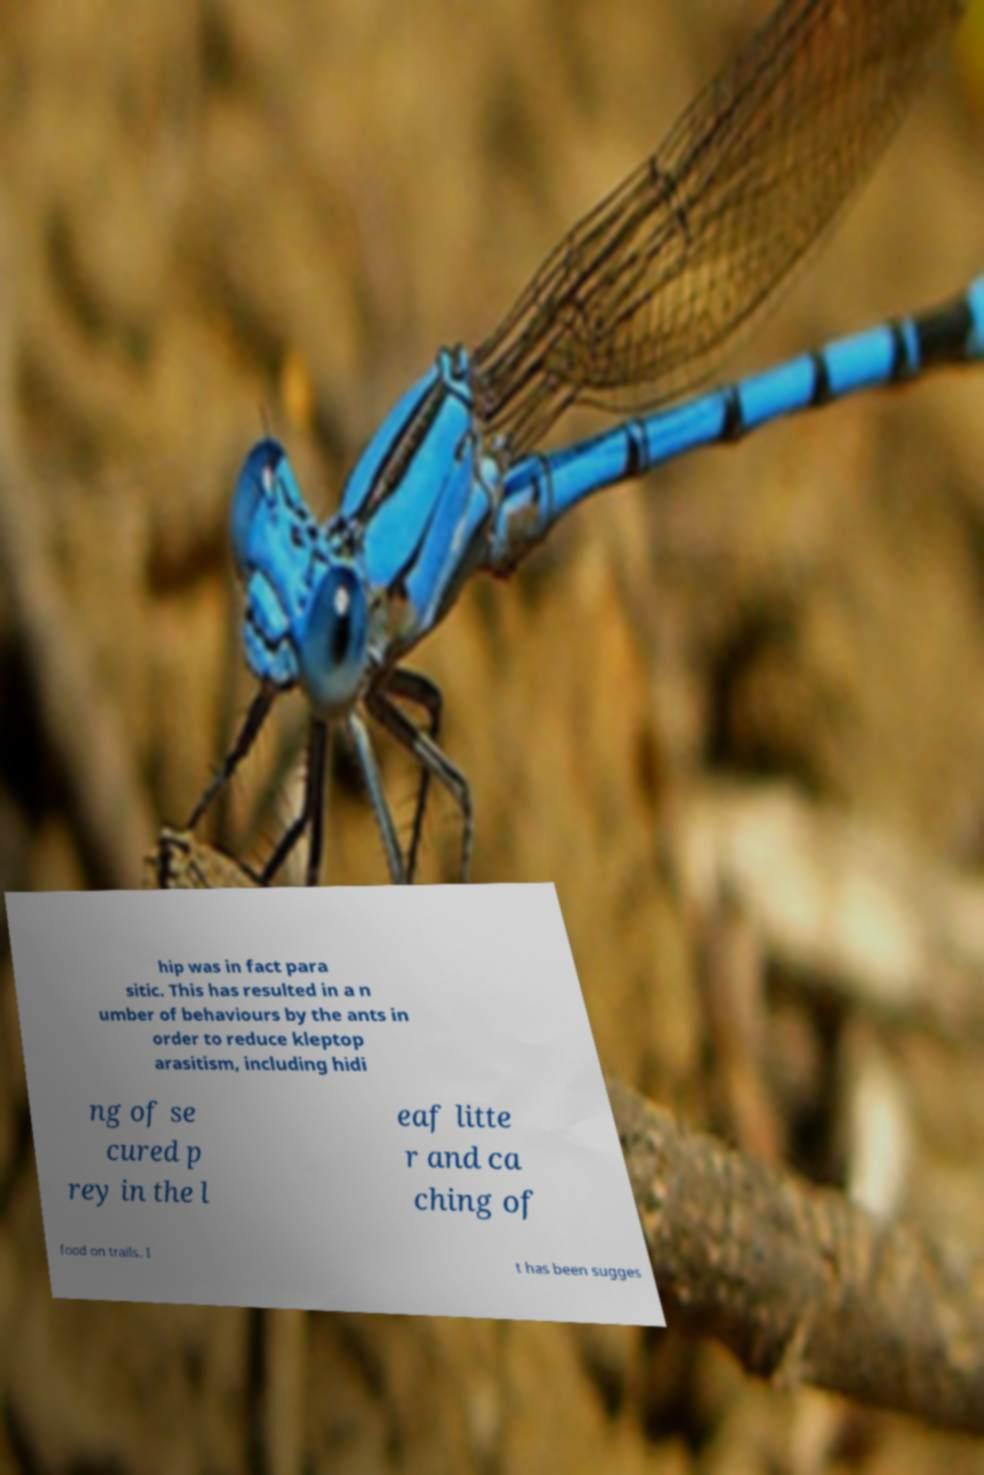For documentation purposes, I need the text within this image transcribed. Could you provide that? hip was in fact para sitic. This has resulted in a n umber of behaviours by the ants in order to reduce kleptop arasitism, including hidi ng of se cured p rey in the l eaf litte r and ca ching of food on trails. I t has been sugges 